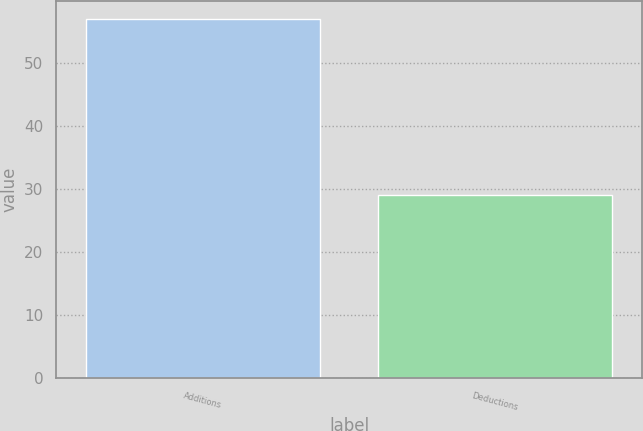Convert chart. <chart><loc_0><loc_0><loc_500><loc_500><bar_chart><fcel>Additions<fcel>Deductions<nl><fcel>57<fcel>29<nl></chart> 